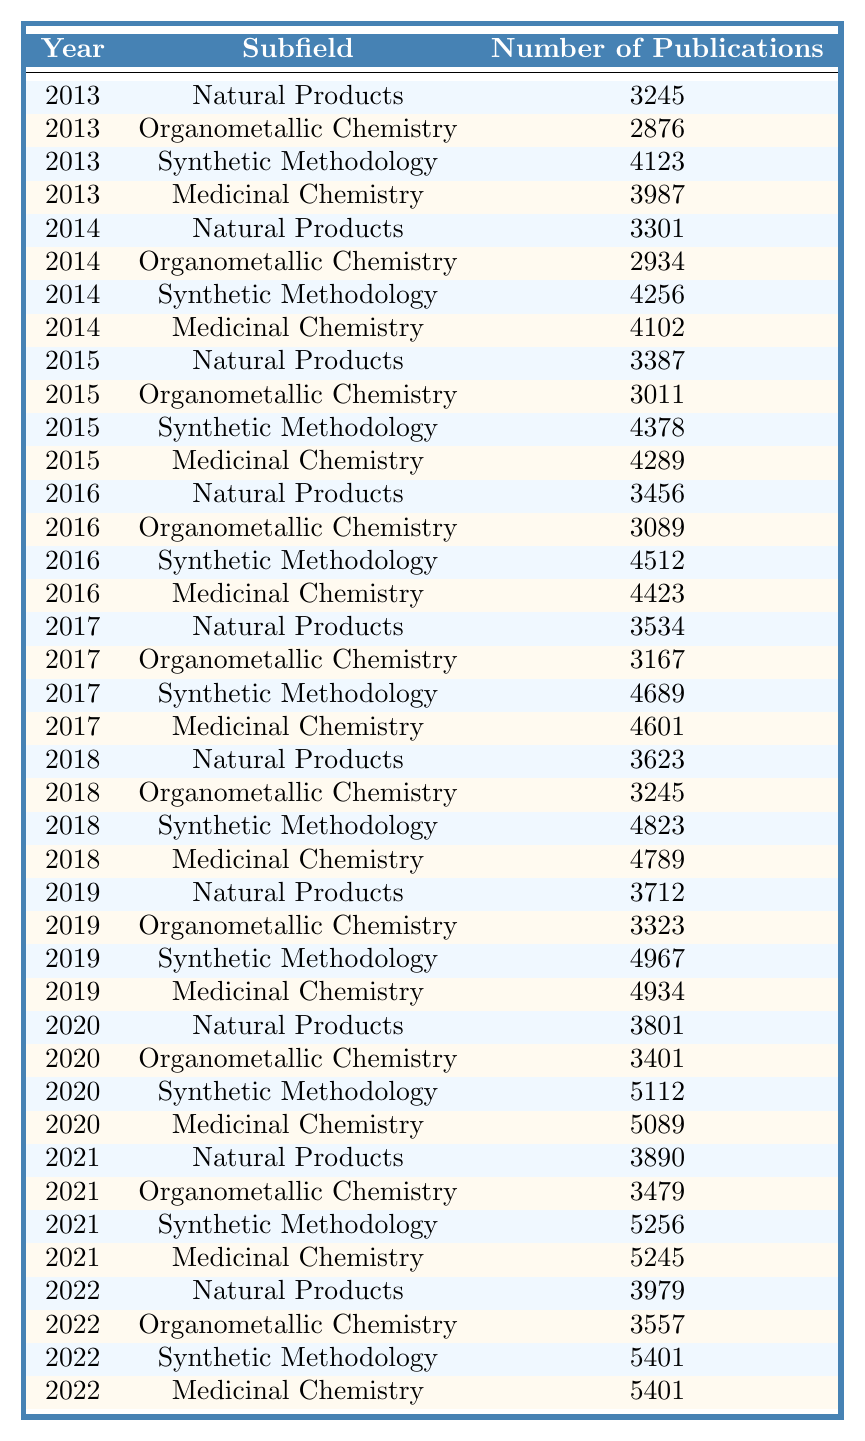What was the total number of publications in 2017 for Medicinal Chemistry? From the table, under the year 2017 in the Medicinal Chemistry row, the number of publications is 4601. Thus, the total for that year in that subfield is simply the number shown.
Answer: 4601 What is the year with the highest number of publications in Natural Products? Looking through the data for Natural Products, the year with the highest number of publications is 2022 with 3979 publications.
Answer: 2022 How many more publications were there in Synthetic Methodology in 2021 compared to 2020? In 2020 the number of publications in Synthetic Methodology is 5112, and in 2021 it is 5256. The difference is 5256 - 5112 = 144.
Answer: 144 What was the average number of publications across all subfields in 2018? For 2018, the publications are: Natural Products (3623), Organometallic Chemistry (3245), Synthetic Methodology (4823), and Medicinal Chemistry (4789). Summing these gives 3623 + 3245 + 4823 + 4789 = 16480. We have 4 subfields, so the average is 16480 / 4 = 4120.
Answer: 4120 Did the number of publications in Medicinal Chemistry increase every year from 2013 to 2022? By examining the table, the number of publications for Medicinal Chemistry goes as follows: 3987 (2013), 4102 (2014), 4289 (2015), 4423 (2016), 4601 (2017), 4789 (2018), 4934 (2019), 5089 (2020), 5245 (2021), and 5401 (2022). Each subsequent year shows an increase, thus confirming that the numbers did rise every year.
Answer: Yes What is the overall trend in publications for Organometallic Chemistry from 2013 to 2022? Analyzing the data points for Organometallic Chemistry: 2876 (2013), 2934 (2014), 3011 (2015), 3089 (2016), 3167 (2017), 3245 (2018), 3323 (2019), 3401 (2020), 3479 (2021), and 3557 (2022), we see a consistent increase each year. This indicates a positive trend over the decade in question.
Answer: Increasing In which year was the least number of publications recorded for Synthetic Methodology? Reviewing the data, the number of publications for Synthetic Methodology per year is: 4123 (2013), 4256 (2014), 4378 (2015), 4512 (2016), 4689 (2017), 4823 (2018), 4967 (2019), 5112 (2020), 5256 (2021), 5401 (2022). The minimum value occurs in the year 2013.
Answer: 2013 What is the percentage increase in the number of publications from Natural Products from 2013 to 2022? The number of publications in 2013 for Natural Products is 3245, and in 2022 it is 3979. The increase is 3979 - 3245 = 734. The percentage increase is calculated as (734 / 3245) * 100, which equals approximately 22.66%.
Answer: 22.66% 